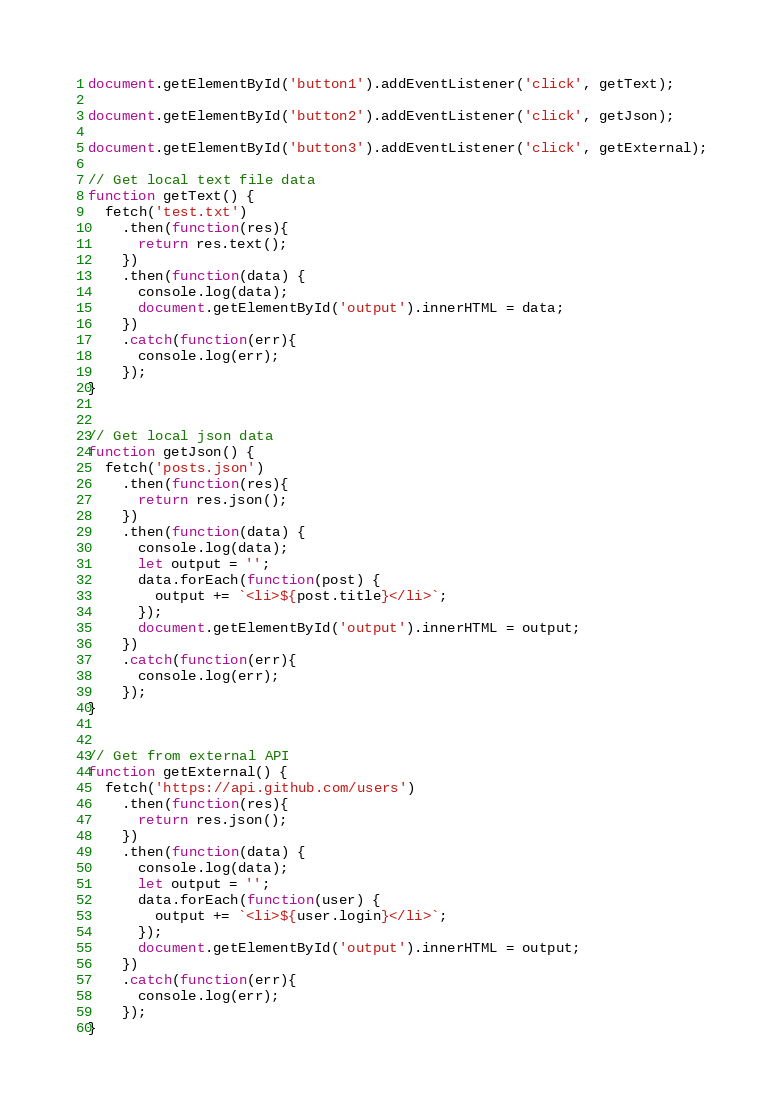<code> <loc_0><loc_0><loc_500><loc_500><_JavaScript_>document.getElementById('button1').addEventListener('click', getText);

document.getElementById('button2').addEventListener('click', getJson);

document.getElementById('button3').addEventListener('click', getExternal);

// Get local text file data
function getText() {
  fetch('test.txt')
    .then(function(res){
      return res.text();
    })
    .then(function(data) {
      console.log(data);
      document.getElementById('output').innerHTML = data;
    })
    .catch(function(err){
      console.log(err);
    });
}


// Get local json data
function getJson() {
  fetch('posts.json')
    .then(function(res){
      return res.json();
    })
    .then(function(data) {
      console.log(data);
      let output = '';
      data.forEach(function(post) {
        output += `<li>${post.title}</li>`;
      });
      document.getElementById('output').innerHTML = output;
    })
    .catch(function(err){
      console.log(err);
    });
}


// Get from external API
function getExternal() {
  fetch('https://api.github.com/users')
    .then(function(res){
      return res.json();
    })
    .then(function(data) {
      console.log(data);
      let output = '';
      data.forEach(function(user) {
        output += `<li>${user.login}</li>`;
      });
      document.getElementById('output').innerHTML = output;
    })
    .catch(function(err){
      console.log(err);
    });
}</code> 